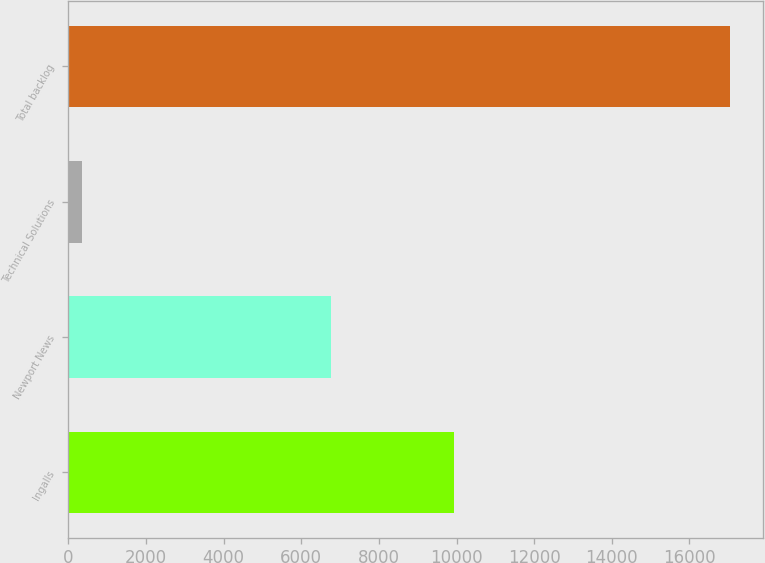<chart> <loc_0><loc_0><loc_500><loc_500><bar_chart><fcel>Ingalls<fcel>Newport News<fcel>Technical Solutions<fcel>Total backlog<nl><fcel>9943<fcel>6767<fcel>339<fcel>17049<nl></chart> 